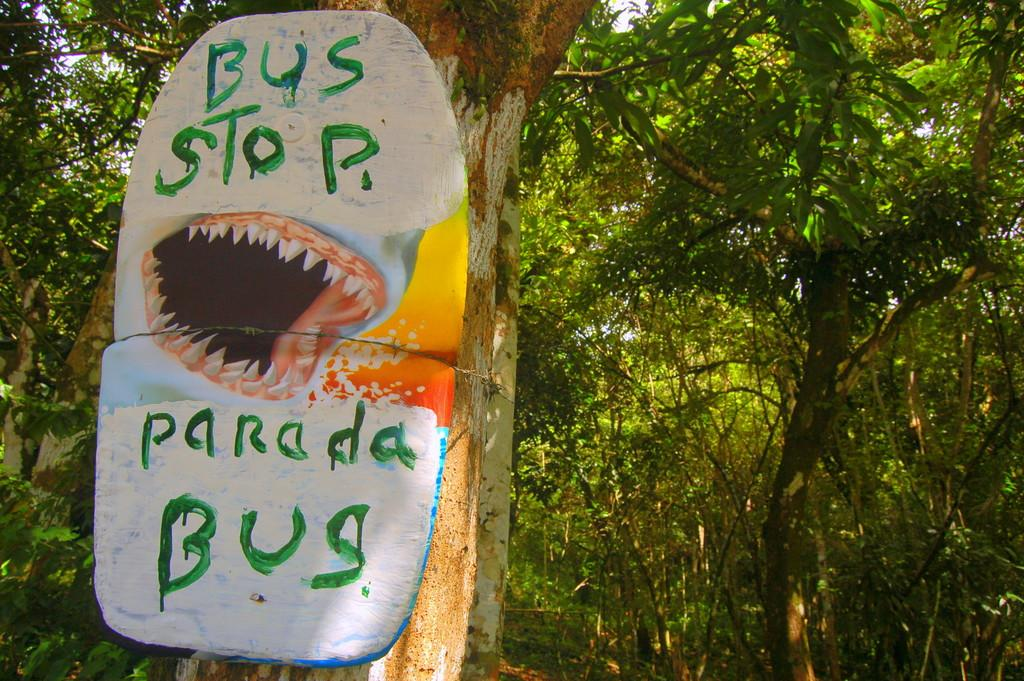What is the main object in the image? There is a tree branch in the image. What else can be seen in the image besides the tree branch? There is a board in the image. What is written on the board? The board has the text "parada bus" written on it. What symbol is present on the board? The board has a teeth symbol. What can be seen in the background of the image? There are trees visible behind the tree branch. How does the rat contribute to the wealth of the people in the image? There is no rat present in the image, so it cannot contribute to anyone's wealth. What is the cause of death for the person in the image? There is no person or indication of death in the image. 